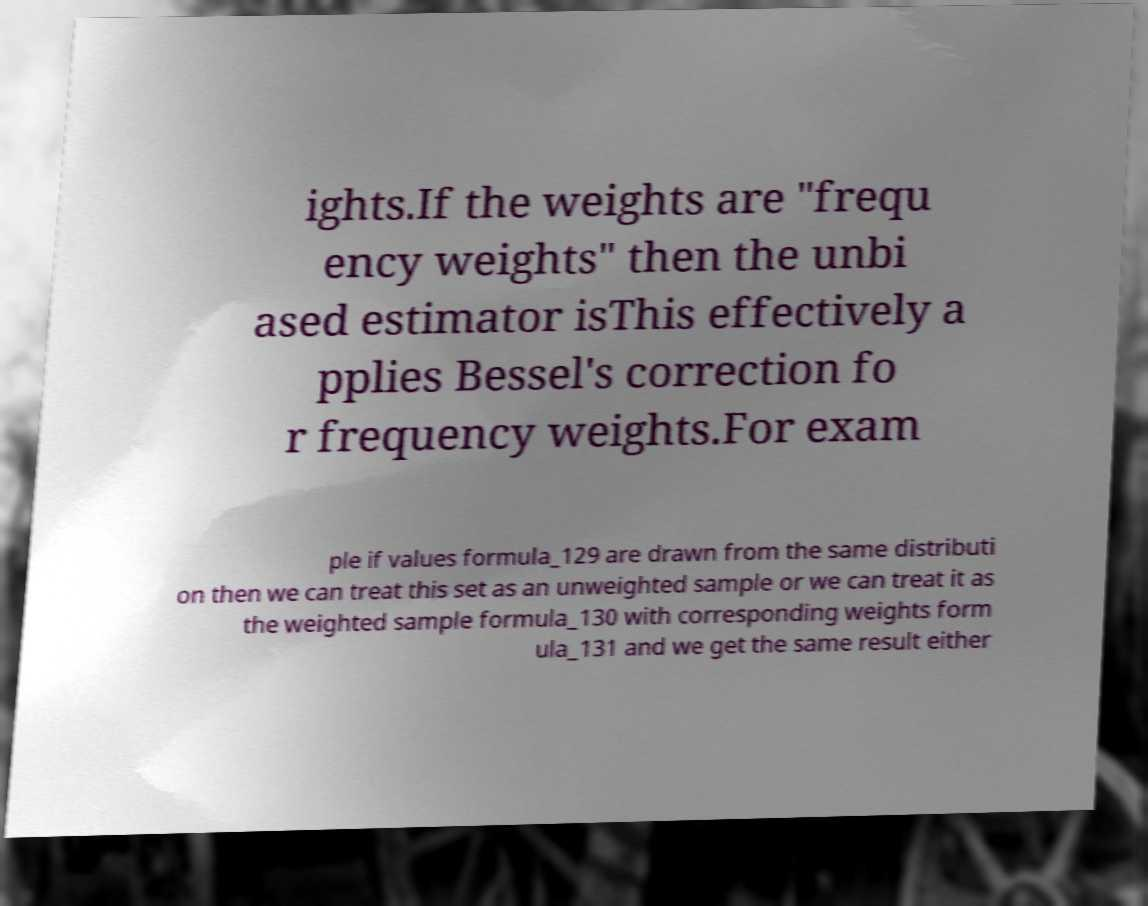Could you assist in decoding the text presented in this image and type it out clearly? ights.If the weights are "frequ ency weights" then the unbi ased estimator isThis effectively a pplies Bessel's correction fo r frequency weights.For exam ple if values formula_129 are drawn from the same distributi on then we can treat this set as an unweighted sample or we can treat it as the weighted sample formula_130 with corresponding weights form ula_131 and we get the same result either 